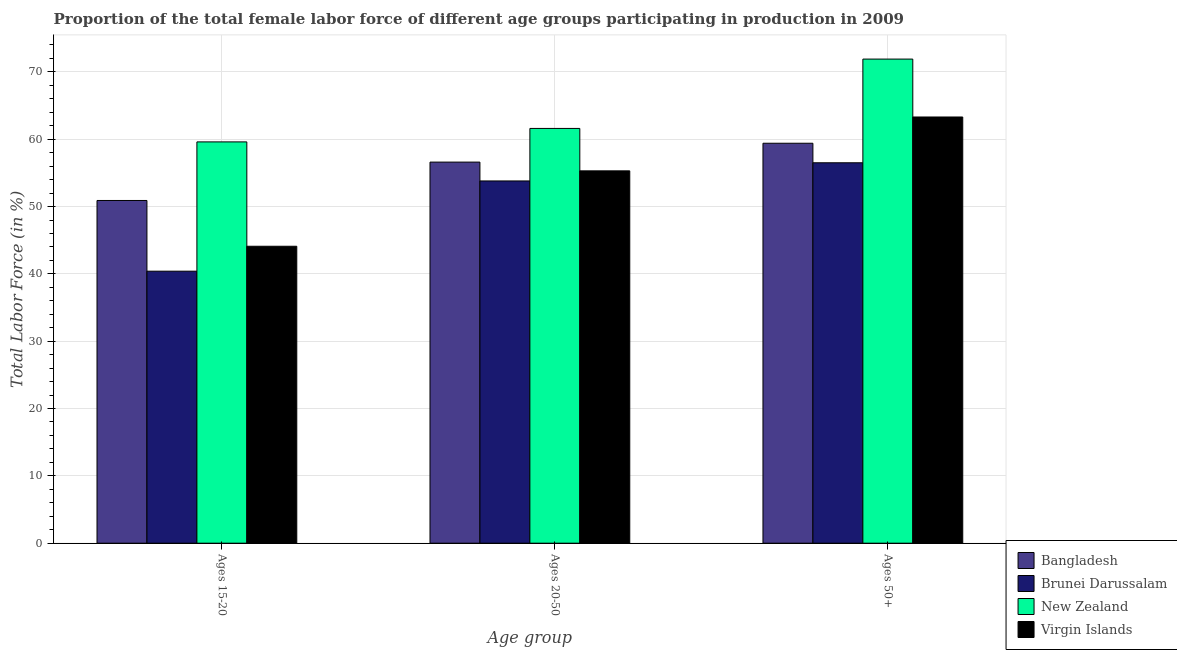How many different coloured bars are there?
Give a very brief answer. 4. Are the number of bars on each tick of the X-axis equal?
Offer a terse response. Yes. How many bars are there on the 1st tick from the left?
Your response must be concise. 4. What is the label of the 3rd group of bars from the left?
Your response must be concise. Ages 50+. What is the percentage of female labor force within the age group 20-50 in Virgin Islands?
Give a very brief answer. 55.3. Across all countries, what is the maximum percentage of female labor force above age 50?
Your answer should be compact. 71.9. Across all countries, what is the minimum percentage of female labor force above age 50?
Give a very brief answer. 56.5. In which country was the percentage of female labor force above age 50 maximum?
Offer a terse response. New Zealand. In which country was the percentage of female labor force within the age group 20-50 minimum?
Your answer should be very brief. Brunei Darussalam. What is the total percentage of female labor force above age 50 in the graph?
Make the answer very short. 251.1. What is the difference between the percentage of female labor force within the age group 15-20 in New Zealand and that in Bangladesh?
Your answer should be very brief. 8.7. What is the difference between the percentage of female labor force within the age group 15-20 in Brunei Darussalam and the percentage of female labor force within the age group 20-50 in Bangladesh?
Provide a short and direct response. -16.2. What is the average percentage of female labor force within the age group 20-50 per country?
Provide a short and direct response. 56.82. What is the difference between the percentage of female labor force within the age group 20-50 and percentage of female labor force above age 50 in New Zealand?
Make the answer very short. -10.3. What is the ratio of the percentage of female labor force within the age group 20-50 in New Zealand to that in Virgin Islands?
Offer a very short reply. 1.11. Is the percentage of female labor force within the age group 15-20 in New Zealand less than that in Brunei Darussalam?
Your answer should be compact. No. Is the difference between the percentage of female labor force within the age group 15-20 in New Zealand and Bangladesh greater than the difference between the percentage of female labor force within the age group 20-50 in New Zealand and Bangladesh?
Provide a succinct answer. Yes. What is the difference between the highest and the second highest percentage of female labor force above age 50?
Your response must be concise. 8.6. What is the difference between the highest and the lowest percentage of female labor force above age 50?
Ensure brevity in your answer.  15.4. What does the 1st bar from the left in Ages 20-50 represents?
Provide a succinct answer. Bangladesh. What does the 3rd bar from the right in Ages 20-50 represents?
Make the answer very short. Brunei Darussalam. Is it the case that in every country, the sum of the percentage of female labor force within the age group 15-20 and percentage of female labor force within the age group 20-50 is greater than the percentage of female labor force above age 50?
Provide a succinct answer. Yes. How many bars are there?
Your answer should be very brief. 12. What is the difference between two consecutive major ticks on the Y-axis?
Your response must be concise. 10. Are the values on the major ticks of Y-axis written in scientific E-notation?
Make the answer very short. No. Does the graph contain any zero values?
Offer a terse response. No. How many legend labels are there?
Ensure brevity in your answer.  4. What is the title of the graph?
Keep it short and to the point. Proportion of the total female labor force of different age groups participating in production in 2009. Does "Bangladesh" appear as one of the legend labels in the graph?
Keep it short and to the point. Yes. What is the label or title of the X-axis?
Offer a very short reply. Age group. What is the label or title of the Y-axis?
Your answer should be compact. Total Labor Force (in %). What is the Total Labor Force (in %) of Bangladesh in Ages 15-20?
Offer a very short reply. 50.9. What is the Total Labor Force (in %) in Brunei Darussalam in Ages 15-20?
Offer a terse response. 40.4. What is the Total Labor Force (in %) of New Zealand in Ages 15-20?
Offer a terse response. 59.6. What is the Total Labor Force (in %) in Virgin Islands in Ages 15-20?
Your answer should be compact. 44.1. What is the Total Labor Force (in %) of Bangladesh in Ages 20-50?
Provide a succinct answer. 56.6. What is the Total Labor Force (in %) of Brunei Darussalam in Ages 20-50?
Ensure brevity in your answer.  53.8. What is the Total Labor Force (in %) of New Zealand in Ages 20-50?
Offer a terse response. 61.6. What is the Total Labor Force (in %) of Virgin Islands in Ages 20-50?
Ensure brevity in your answer.  55.3. What is the Total Labor Force (in %) in Bangladesh in Ages 50+?
Your answer should be very brief. 59.4. What is the Total Labor Force (in %) in Brunei Darussalam in Ages 50+?
Offer a very short reply. 56.5. What is the Total Labor Force (in %) in New Zealand in Ages 50+?
Your answer should be very brief. 71.9. What is the Total Labor Force (in %) in Virgin Islands in Ages 50+?
Provide a short and direct response. 63.3. Across all Age group, what is the maximum Total Labor Force (in %) in Bangladesh?
Your answer should be very brief. 59.4. Across all Age group, what is the maximum Total Labor Force (in %) of Brunei Darussalam?
Your answer should be very brief. 56.5. Across all Age group, what is the maximum Total Labor Force (in %) in New Zealand?
Make the answer very short. 71.9. Across all Age group, what is the maximum Total Labor Force (in %) of Virgin Islands?
Your answer should be compact. 63.3. Across all Age group, what is the minimum Total Labor Force (in %) in Bangladesh?
Your response must be concise. 50.9. Across all Age group, what is the minimum Total Labor Force (in %) of Brunei Darussalam?
Offer a terse response. 40.4. Across all Age group, what is the minimum Total Labor Force (in %) of New Zealand?
Make the answer very short. 59.6. Across all Age group, what is the minimum Total Labor Force (in %) of Virgin Islands?
Ensure brevity in your answer.  44.1. What is the total Total Labor Force (in %) in Bangladesh in the graph?
Your answer should be compact. 166.9. What is the total Total Labor Force (in %) of Brunei Darussalam in the graph?
Provide a short and direct response. 150.7. What is the total Total Labor Force (in %) in New Zealand in the graph?
Make the answer very short. 193.1. What is the total Total Labor Force (in %) in Virgin Islands in the graph?
Ensure brevity in your answer.  162.7. What is the difference between the Total Labor Force (in %) in Brunei Darussalam in Ages 15-20 and that in Ages 20-50?
Your answer should be very brief. -13.4. What is the difference between the Total Labor Force (in %) in Brunei Darussalam in Ages 15-20 and that in Ages 50+?
Provide a succinct answer. -16.1. What is the difference between the Total Labor Force (in %) of Virgin Islands in Ages 15-20 and that in Ages 50+?
Make the answer very short. -19.2. What is the difference between the Total Labor Force (in %) of Bangladesh in Ages 20-50 and that in Ages 50+?
Ensure brevity in your answer.  -2.8. What is the difference between the Total Labor Force (in %) in Brunei Darussalam in Ages 20-50 and that in Ages 50+?
Ensure brevity in your answer.  -2.7. What is the difference between the Total Labor Force (in %) in Virgin Islands in Ages 20-50 and that in Ages 50+?
Your response must be concise. -8. What is the difference between the Total Labor Force (in %) in Bangladesh in Ages 15-20 and the Total Labor Force (in %) in Brunei Darussalam in Ages 20-50?
Provide a succinct answer. -2.9. What is the difference between the Total Labor Force (in %) of Bangladesh in Ages 15-20 and the Total Labor Force (in %) of New Zealand in Ages 20-50?
Offer a very short reply. -10.7. What is the difference between the Total Labor Force (in %) in Brunei Darussalam in Ages 15-20 and the Total Labor Force (in %) in New Zealand in Ages 20-50?
Give a very brief answer. -21.2. What is the difference between the Total Labor Force (in %) in Brunei Darussalam in Ages 15-20 and the Total Labor Force (in %) in Virgin Islands in Ages 20-50?
Your answer should be very brief. -14.9. What is the difference between the Total Labor Force (in %) of New Zealand in Ages 15-20 and the Total Labor Force (in %) of Virgin Islands in Ages 20-50?
Offer a very short reply. 4.3. What is the difference between the Total Labor Force (in %) in Bangladesh in Ages 15-20 and the Total Labor Force (in %) in New Zealand in Ages 50+?
Your answer should be very brief. -21. What is the difference between the Total Labor Force (in %) of Bangladesh in Ages 15-20 and the Total Labor Force (in %) of Virgin Islands in Ages 50+?
Provide a short and direct response. -12.4. What is the difference between the Total Labor Force (in %) in Brunei Darussalam in Ages 15-20 and the Total Labor Force (in %) in New Zealand in Ages 50+?
Keep it short and to the point. -31.5. What is the difference between the Total Labor Force (in %) in Brunei Darussalam in Ages 15-20 and the Total Labor Force (in %) in Virgin Islands in Ages 50+?
Make the answer very short. -22.9. What is the difference between the Total Labor Force (in %) of New Zealand in Ages 15-20 and the Total Labor Force (in %) of Virgin Islands in Ages 50+?
Your answer should be very brief. -3.7. What is the difference between the Total Labor Force (in %) of Bangladesh in Ages 20-50 and the Total Labor Force (in %) of New Zealand in Ages 50+?
Give a very brief answer. -15.3. What is the difference between the Total Labor Force (in %) in Brunei Darussalam in Ages 20-50 and the Total Labor Force (in %) in New Zealand in Ages 50+?
Your answer should be compact. -18.1. What is the average Total Labor Force (in %) in Bangladesh per Age group?
Give a very brief answer. 55.63. What is the average Total Labor Force (in %) of Brunei Darussalam per Age group?
Your answer should be compact. 50.23. What is the average Total Labor Force (in %) of New Zealand per Age group?
Ensure brevity in your answer.  64.37. What is the average Total Labor Force (in %) of Virgin Islands per Age group?
Offer a very short reply. 54.23. What is the difference between the Total Labor Force (in %) in Bangladesh and Total Labor Force (in %) in Brunei Darussalam in Ages 15-20?
Your response must be concise. 10.5. What is the difference between the Total Labor Force (in %) in Bangladesh and Total Labor Force (in %) in New Zealand in Ages 15-20?
Provide a short and direct response. -8.7. What is the difference between the Total Labor Force (in %) in Brunei Darussalam and Total Labor Force (in %) in New Zealand in Ages 15-20?
Ensure brevity in your answer.  -19.2. What is the difference between the Total Labor Force (in %) of Brunei Darussalam and Total Labor Force (in %) of Virgin Islands in Ages 15-20?
Make the answer very short. -3.7. What is the difference between the Total Labor Force (in %) of New Zealand and Total Labor Force (in %) of Virgin Islands in Ages 15-20?
Your answer should be very brief. 15.5. What is the difference between the Total Labor Force (in %) of Bangladesh and Total Labor Force (in %) of Brunei Darussalam in Ages 20-50?
Your answer should be compact. 2.8. What is the difference between the Total Labor Force (in %) of Brunei Darussalam and Total Labor Force (in %) of Virgin Islands in Ages 20-50?
Give a very brief answer. -1.5. What is the difference between the Total Labor Force (in %) in New Zealand and Total Labor Force (in %) in Virgin Islands in Ages 20-50?
Your answer should be very brief. 6.3. What is the difference between the Total Labor Force (in %) in Brunei Darussalam and Total Labor Force (in %) in New Zealand in Ages 50+?
Make the answer very short. -15.4. What is the difference between the Total Labor Force (in %) of Brunei Darussalam and Total Labor Force (in %) of Virgin Islands in Ages 50+?
Provide a succinct answer. -6.8. What is the difference between the Total Labor Force (in %) of New Zealand and Total Labor Force (in %) of Virgin Islands in Ages 50+?
Give a very brief answer. 8.6. What is the ratio of the Total Labor Force (in %) of Bangladesh in Ages 15-20 to that in Ages 20-50?
Your answer should be very brief. 0.9. What is the ratio of the Total Labor Force (in %) of Brunei Darussalam in Ages 15-20 to that in Ages 20-50?
Offer a terse response. 0.75. What is the ratio of the Total Labor Force (in %) of New Zealand in Ages 15-20 to that in Ages 20-50?
Offer a very short reply. 0.97. What is the ratio of the Total Labor Force (in %) of Virgin Islands in Ages 15-20 to that in Ages 20-50?
Give a very brief answer. 0.8. What is the ratio of the Total Labor Force (in %) in Bangladesh in Ages 15-20 to that in Ages 50+?
Your answer should be compact. 0.86. What is the ratio of the Total Labor Force (in %) of Brunei Darussalam in Ages 15-20 to that in Ages 50+?
Provide a short and direct response. 0.71. What is the ratio of the Total Labor Force (in %) of New Zealand in Ages 15-20 to that in Ages 50+?
Your answer should be very brief. 0.83. What is the ratio of the Total Labor Force (in %) of Virgin Islands in Ages 15-20 to that in Ages 50+?
Provide a succinct answer. 0.7. What is the ratio of the Total Labor Force (in %) in Bangladesh in Ages 20-50 to that in Ages 50+?
Your answer should be compact. 0.95. What is the ratio of the Total Labor Force (in %) in Brunei Darussalam in Ages 20-50 to that in Ages 50+?
Make the answer very short. 0.95. What is the ratio of the Total Labor Force (in %) of New Zealand in Ages 20-50 to that in Ages 50+?
Your answer should be compact. 0.86. What is the ratio of the Total Labor Force (in %) in Virgin Islands in Ages 20-50 to that in Ages 50+?
Provide a short and direct response. 0.87. What is the difference between the highest and the second highest Total Labor Force (in %) of Virgin Islands?
Make the answer very short. 8. What is the difference between the highest and the lowest Total Labor Force (in %) in Bangladesh?
Make the answer very short. 8.5. What is the difference between the highest and the lowest Total Labor Force (in %) in Virgin Islands?
Make the answer very short. 19.2. 